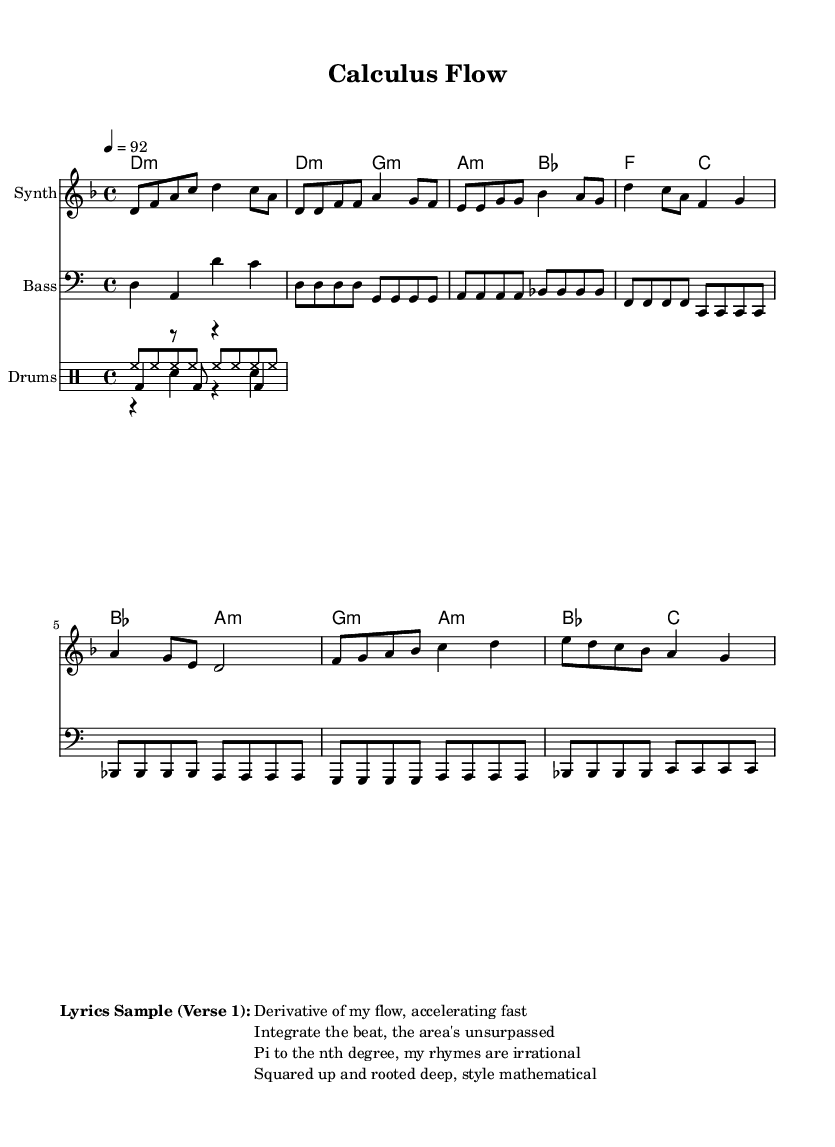What is the key signature of this music? The key signature is indicated at the beginning of the staff. In this case, it shows one flat (B♭), which means the key is D minor.
Answer: D minor What is the time signature of the piece? The time signature is represented in the music notation, and here it is indicated as 4/4, meaning there are four beats in each measure and the quarter note gets one beat.
Answer: 4/4 What is the tempo marking of the music? The tempo is provided near the top of the score, where it states "4 = 92." This means that there are 92 beats per minute, and the quarter note is the unit of measurement for tempo.
Answer: 92 What is the duration of the first measure in beats? Each note in the first measure is counted, where d8 (eighth note) + f (eighth note) + a (eighth note) + c (eighth note) + d4 (quarter note) + c8 (eighth note) + a (eighth note) adds up to 4 beats in total.
Answer: 4 beats What is the primary instrument for the melody? The melody is indicated on the staff labeled "Synth," which means that the primary instrument playing the melody is a synthesizer.
Answer: Synth How many chords are used in the verse? The verse consists of a sequence with 4 unique chords listed under the chord mode: d minor, g minor, a minor, and b flat. This totals 4 chords for the verse section.
Answer: 4 What type of rhythmic patterns do the drums use? The drum section consists of three distinct patterns: a kick drum pattern, a snare drum pattern, and a hi-hat pattern, which together comprise the rhythm for the entire piece, defining it as a hip hop style.
Answer: Hip hop 